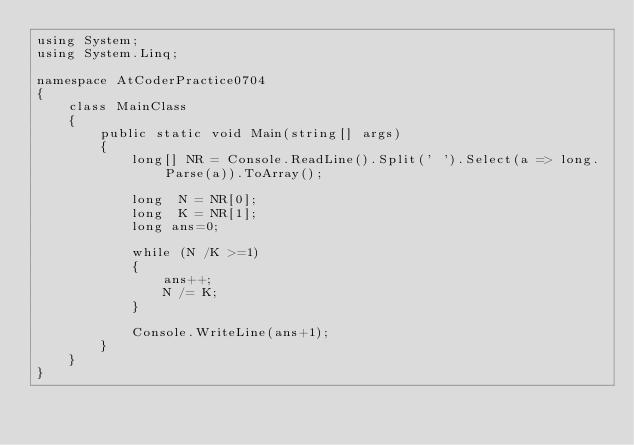Convert code to text. <code><loc_0><loc_0><loc_500><loc_500><_C#_>using System;
using System.Linq;

namespace AtCoderPractice0704
{
    class MainClass
    {
        public static void Main(string[] args)
        {
            long[] NR = Console.ReadLine().Split(' ').Select(a => long.Parse(a)).ToArray();

            long  N = NR[0];
            long  K = NR[1];
            long ans=0;

            while (N /K >=1)
            {
                ans++;
                N /= K;
            }

            Console.WriteLine(ans+1);
        }
    }
}
</code> 